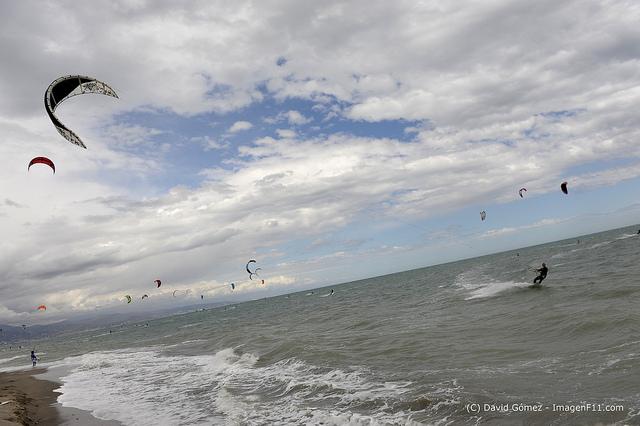Does this look like fun?
Write a very short answer. Yes. Does the weather appear windy?
Concise answer only. Yes. Could the man be wearing a wetsuit?
Give a very brief answer. Yes. Is there a beach?
Quick response, please. Yes. 